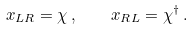<formula> <loc_0><loc_0><loc_500><loc_500>x _ { L R } = \chi \, , \quad x _ { R L } = \chi ^ { \dagger } \, .</formula> 